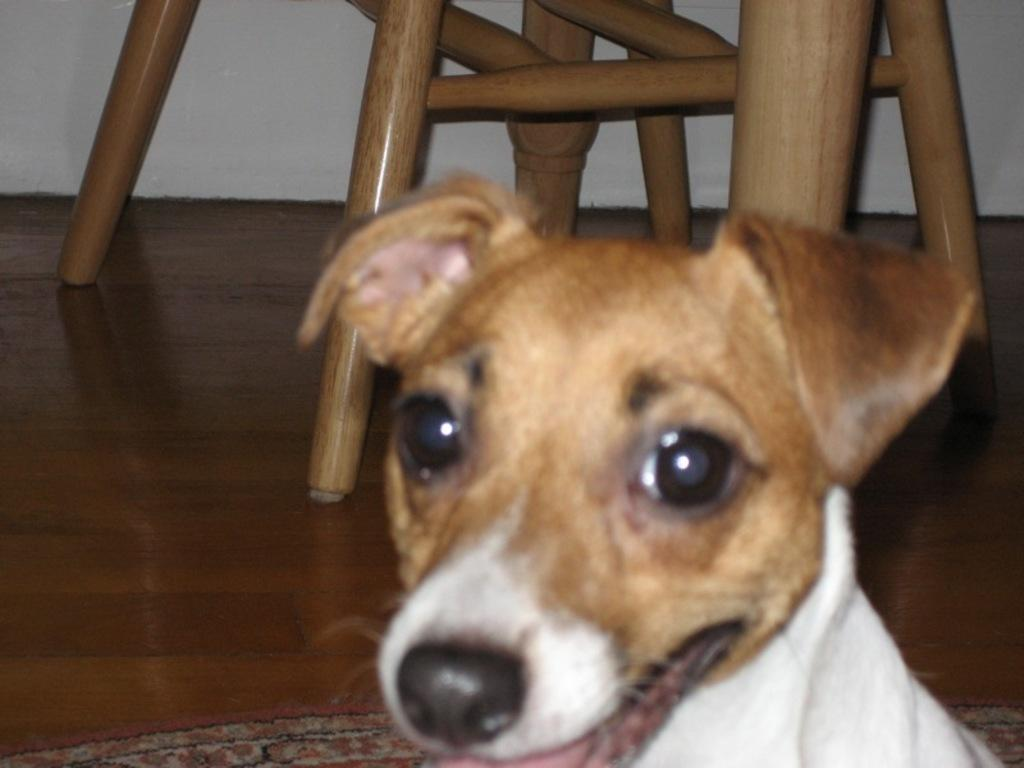What type of animal is in the image? There is a dog in the image. What piece of furniture can be seen in the background? There is a chair in the background of the image. Where is the chair located in relation to the floor? The chair is on the floor. What is visible at the top of the image? There is a wall visible at the top of the image. What type of crib is visible in the image? There is no crib present in the image. What type of crate is visible in the image? There is no crate present in the image. 